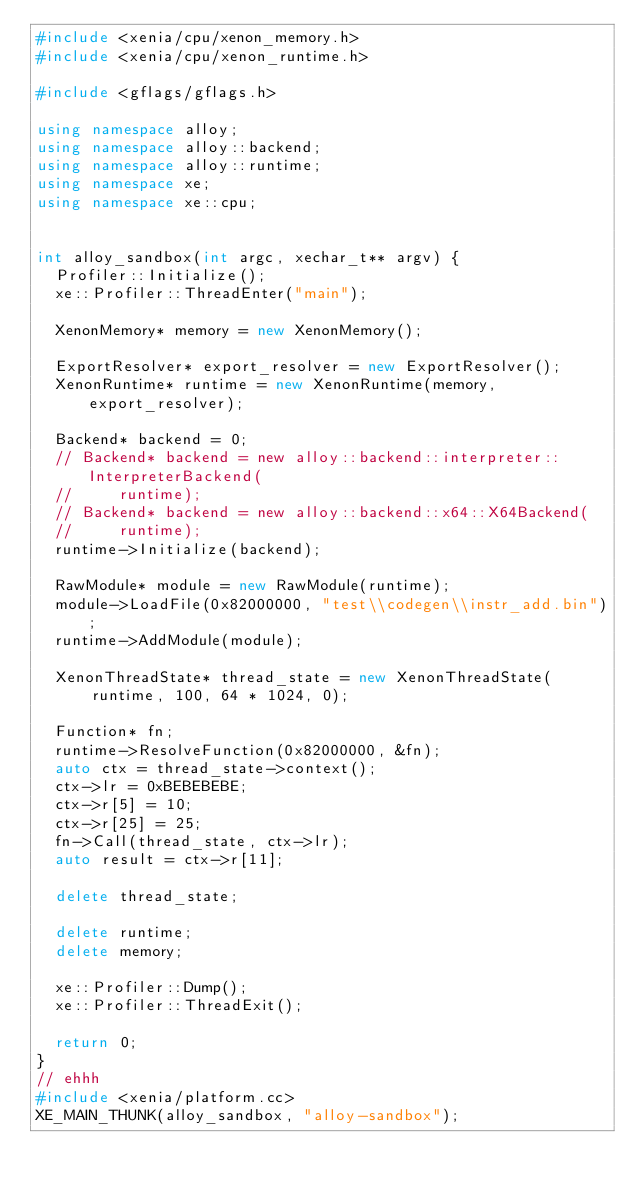<code> <loc_0><loc_0><loc_500><loc_500><_C++_>#include <xenia/cpu/xenon_memory.h>
#include <xenia/cpu/xenon_runtime.h>

#include <gflags/gflags.h>

using namespace alloy;
using namespace alloy::backend;
using namespace alloy::runtime;
using namespace xe;
using namespace xe::cpu;


int alloy_sandbox(int argc, xechar_t** argv) {
  Profiler::Initialize();
  xe::Profiler::ThreadEnter("main");

  XenonMemory* memory = new XenonMemory();

  ExportResolver* export_resolver = new ExportResolver();
  XenonRuntime* runtime = new XenonRuntime(memory, export_resolver);

  Backend* backend = 0;
  // Backend* backend = new alloy::backend::interpreter::InterpreterBackend(
  //     runtime);
  // Backend* backend = new alloy::backend::x64::X64Backend(
  //     runtime);
  runtime->Initialize(backend);

  RawModule* module = new RawModule(runtime);
  module->LoadFile(0x82000000, "test\\codegen\\instr_add.bin");
  runtime->AddModule(module);

  XenonThreadState* thread_state = new XenonThreadState(
      runtime, 100, 64 * 1024, 0);

  Function* fn;
  runtime->ResolveFunction(0x82000000, &fn);
  auto ctx = thread_state->context();
  ctx->lr = 0xBEBEBEBE;
  ctx->r[5] = 10;
  ctx->r[25] = 25;
  fn->Call(thread_state, ctx->lr);
  auto result = ctx->r[11];

  delete thread_state;

  delete runtime;
  delete memory;

  xe::Profiler::Dump();
  xe::Profiler::ThreadExit();

  return 0;
}
// ehhh
#include <xenia/platform.cc>
XE_MAIN_THUNK(alloy_sandbox, "alloy-sandbox");
</code> 